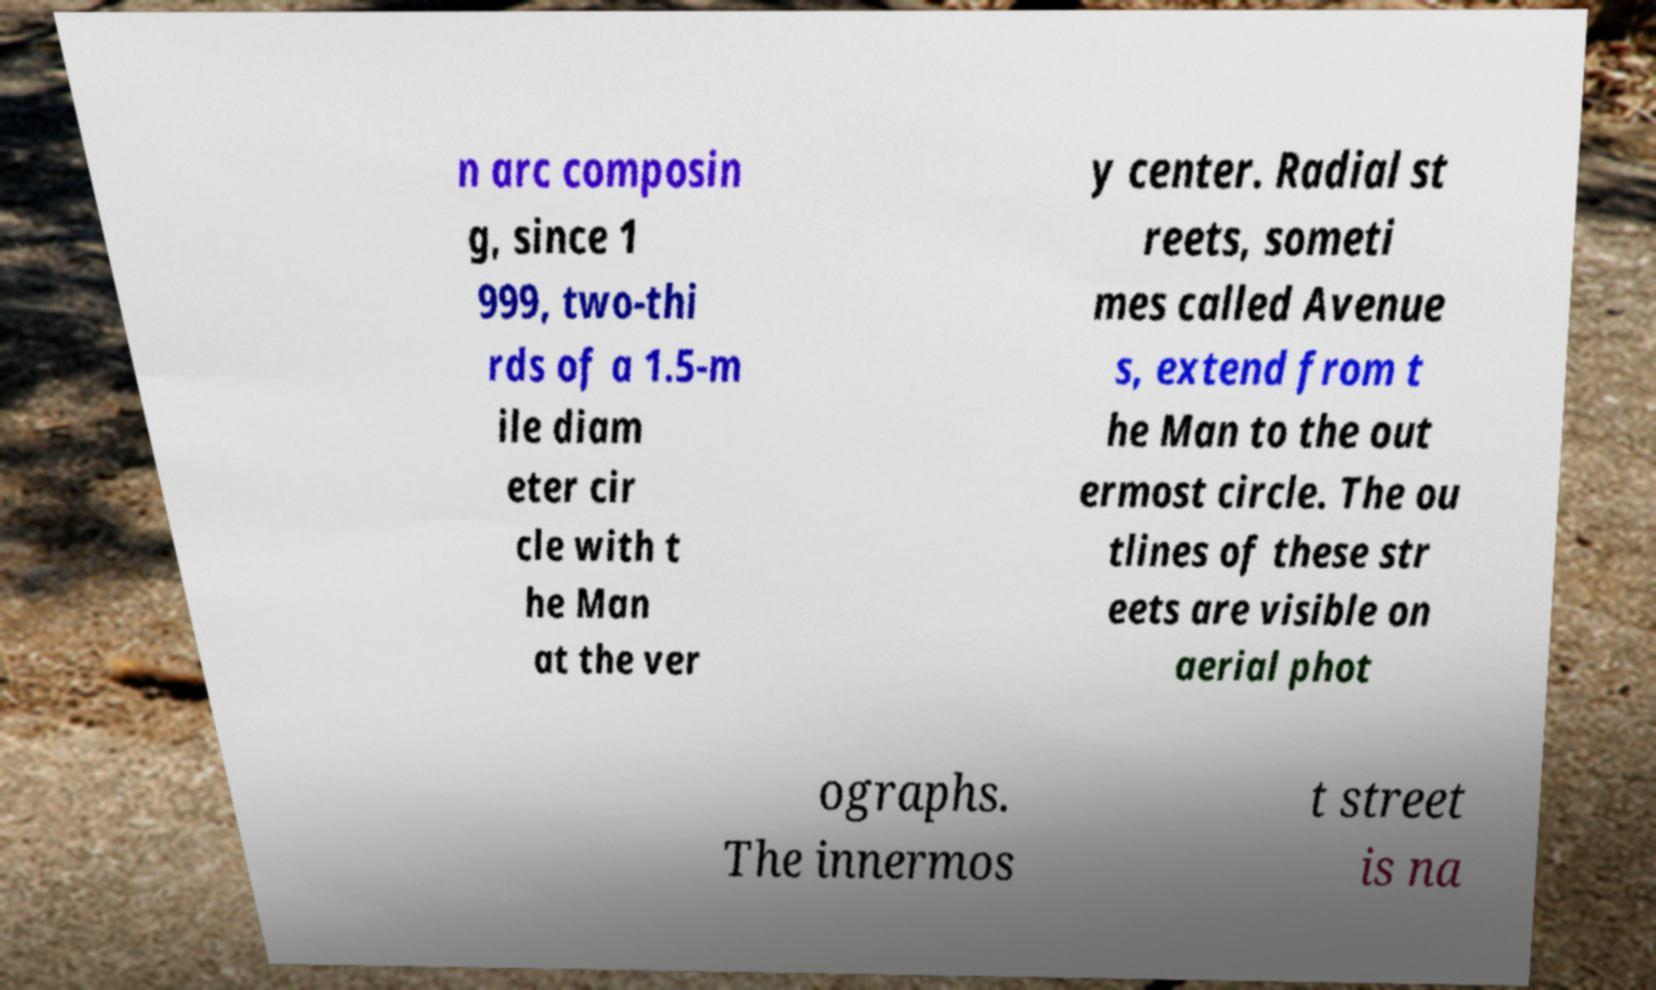Please read and relay the text visible in this image. What does it say? n arc composin g, since 1 999, two-thi rds of a 1.5-m ile diam eter cir cle with t he Man at the ver y center. Radial st reets, someti mes called Avenue s, extend from t he Man to the out ermost circle. The ou tlines of these str eets are visible on aerial phot ographs. The innermos t street is na 